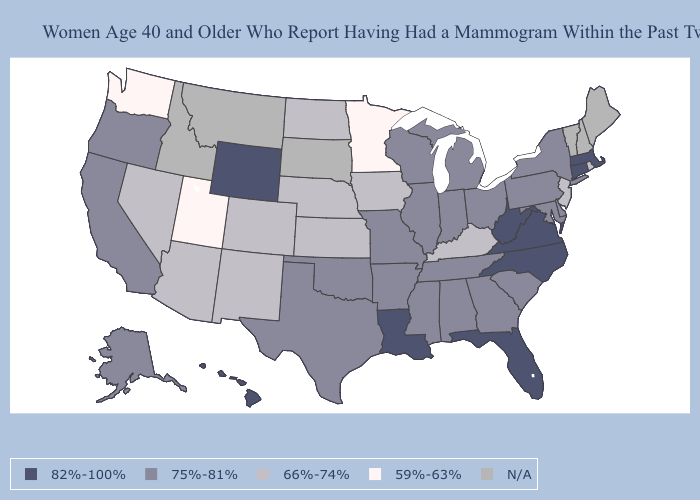Does South Carolina have the lowest value in the USA?
Keep it brief. No. What is the highest value in the USA?
Be succinct. 82%-100%. What is the highest value in the USA?
Answer briefly. 82%-100%. Which states have the highest value in the USA?
Concise answer only. Connecticut, Florida, Hawaii, Louisiana, Massachusetts, North Carolina, Virginia, West Virginia, Wyoming. What is the lowest value in states that border Massachusetts?
Short answer required. 66%-74%. What is the value of Colorado?
Keep it brief. 66%-74%. Which states hav the highest value in the South?
Answer briefly. Florida, Louisiana, North Carolina, Virginia, West Virginia. Name the states that have a value in the range 66%-74%?
Quick response, please. Arizona, Colorado, Iowa, Kansas, Kentucky, Nebraska, Nevada, New Jersey, New Mexico, North Dakota, Rhode Island. What is the value of Rhode Island?
Short answer required. 66%-74%. Which states hav the highest value in the West?
Be succinct. Hawaii, Wyoming. Does Kentucky have the lowest value in the South?
Short answer required. Yes. What is the lowest value in the USA?
Give a very brief answer. 59%-63%. What is the value of Alaska?
Write a very short answer. 75%-81%. 